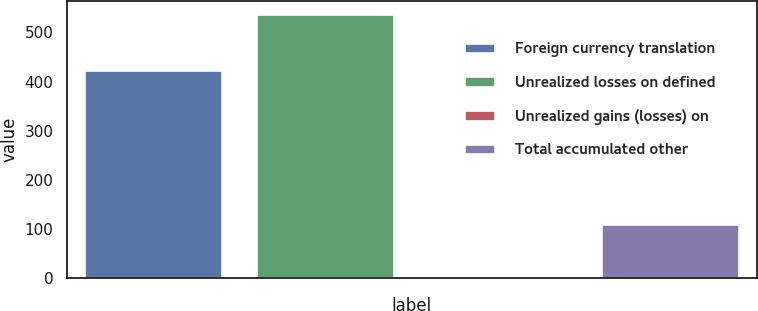<chart> <loc_0><loc_0><loc_500><loc_500><bar_chart><fcel>Foreign currency translation<fcel>Unrealized losses on defined<fcel>Unrealized gains (losses) on<fcel>Total accumulated other<nl><fcel>424<fcel>537<fcel>2<fcel>111<nl></chart> 